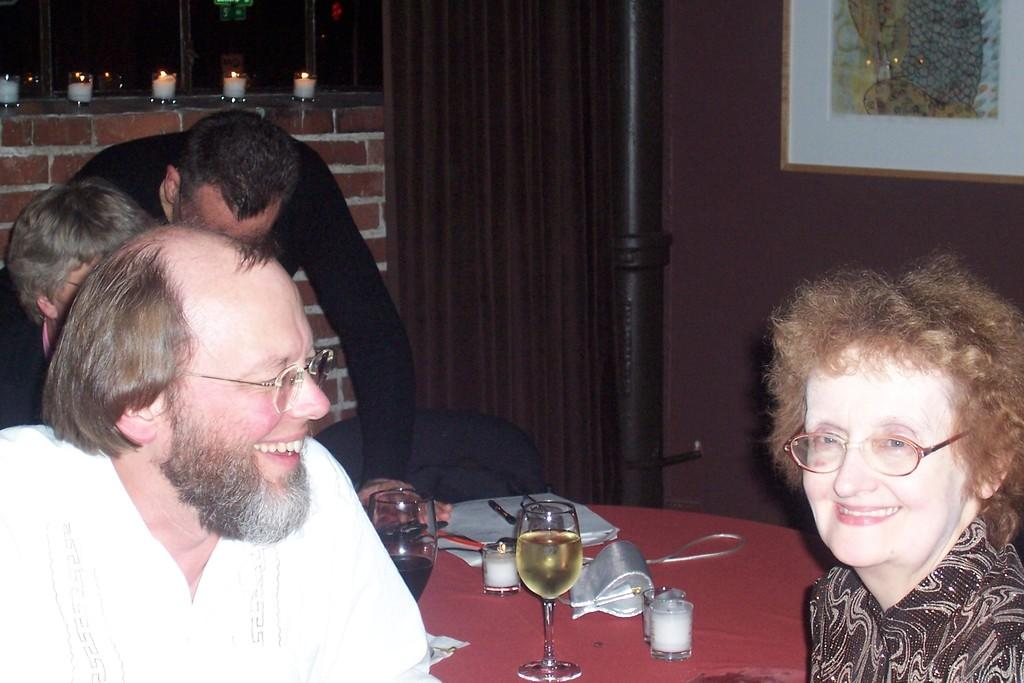How many people are present in the image? There are persons in the image, but the exact number cannot be determined from the provided facts. What is on the table in the image? There are glasses, a book, and other objects on the table in the image. What can be seen on the wall in the background? There is a frame on the wall in the background. What is associated with the window in the background? There is a curtain associated with the window in the background. What is visible in the background of the image? Candles and a window are visible in the background of the image. What type of juice is being served in the image? There is no mention of juice in the provided facts, so it cannot be determined from the image. 